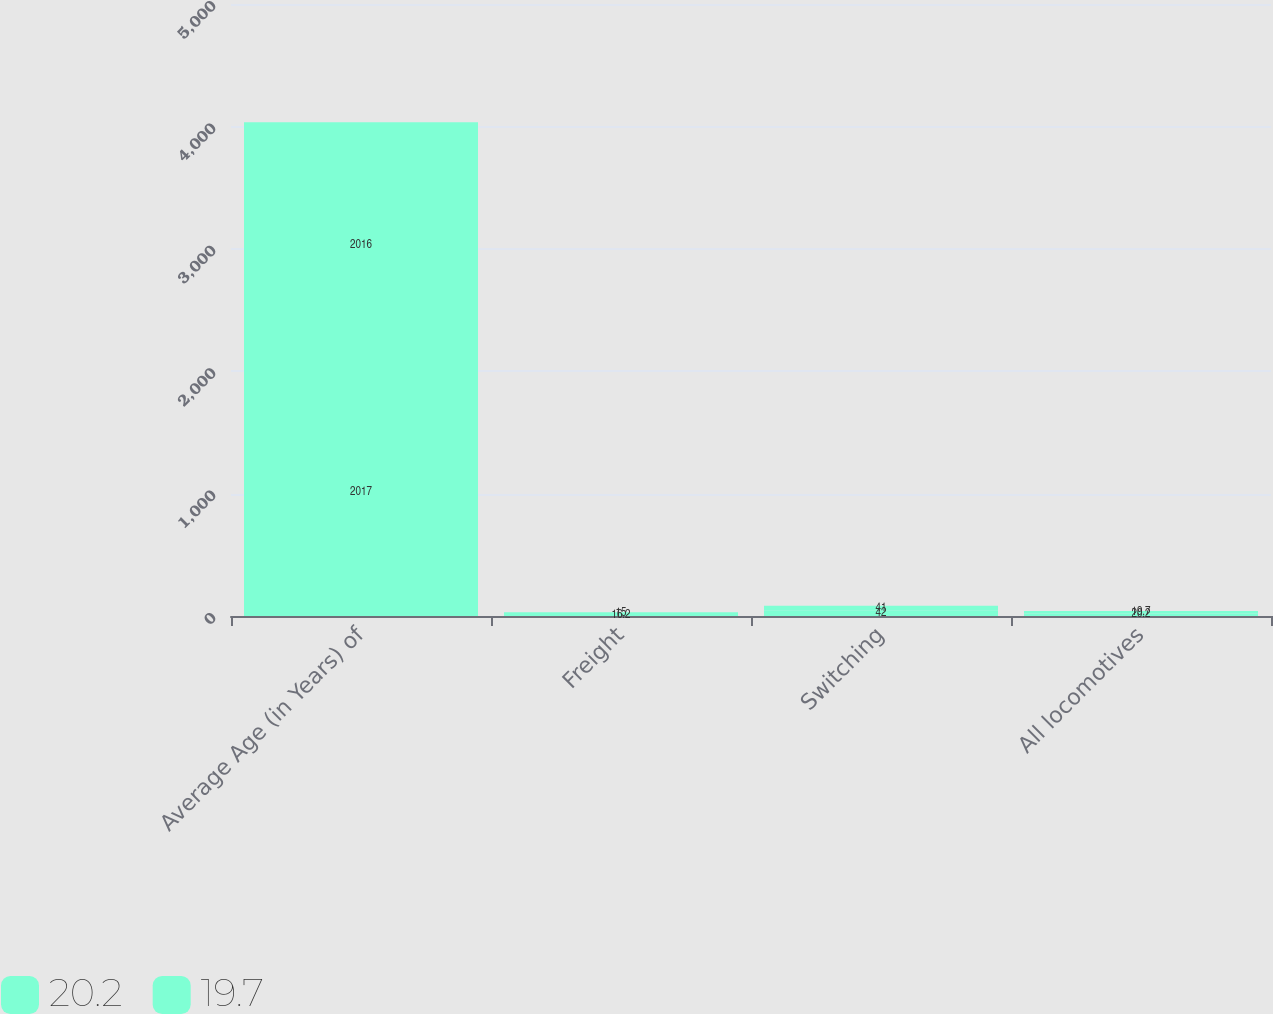Convert chart to OTSL. <chart><loc_0><loc_0><loc_500><loc_500><stacked_bar_chart><ecel><fcel>Average Age (in Years) of<fcel>Freight<fcel>Switching<fcel>All locomotives<nl><fcel>20.2<fcel>2017<fcel>16.2<fcel>42<fcel>20.2<nl><fcel>19.7<fcel>2016<fcel>15<fcel>41<fcel>19.7<nl></chart> 